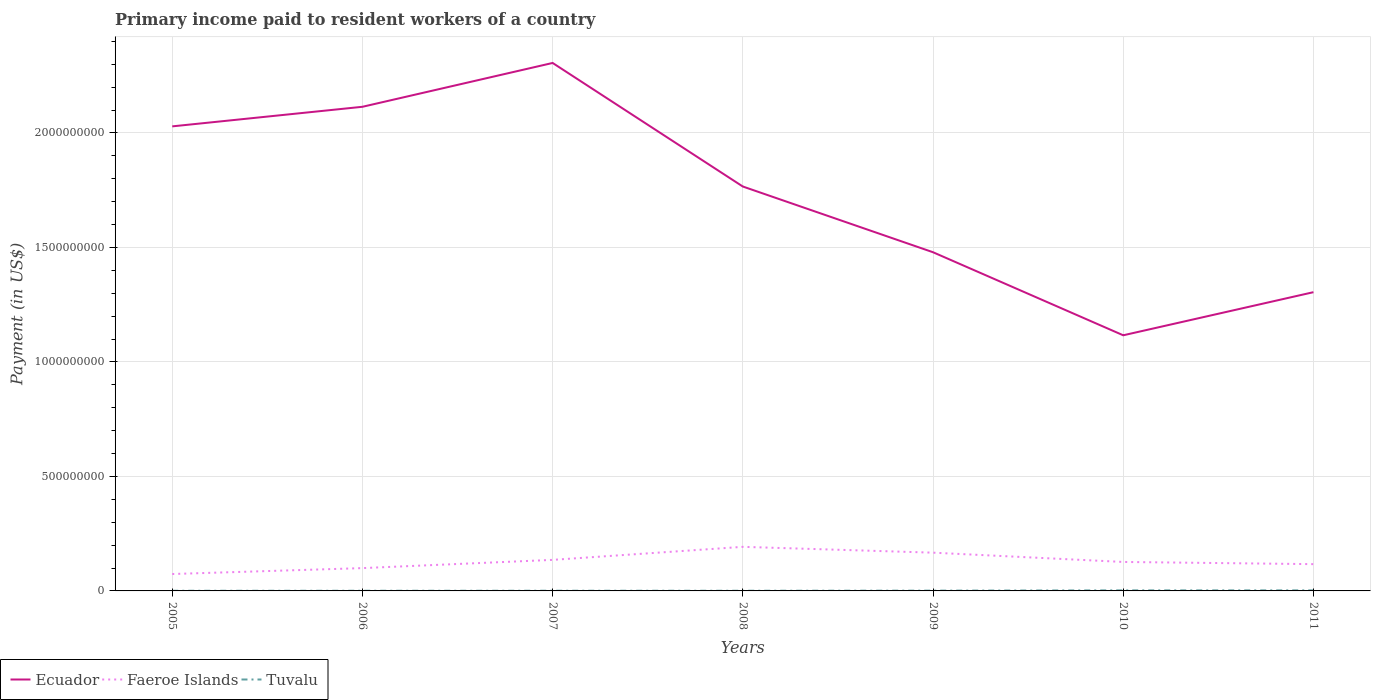Does the line corresponding to Faeroe Islands intersect with the line corresponding to Tuvalu?
Your answer should be compact. No. Across all years, what is the maximum amount paid to workers in Ecuador?
Keep it short and to the point. 1.12e+09. In which year was the amount paid to workers in Faeroe Islands maximum?
Keep it short and to the point. 2005. What is the total amount paid to workers in Tuvalu in the graph?
Your answer should be compact. -1.27e+05. What is the difference between the highest and the second highest amount paid to workers in Ecuador?
Your answer should be compact. 1.19e+09. What is the difference between two consecutive major ticks on the Y-axis?
Give a very brief answer. 5.00e+08. Where does the legend appear in the graph?
Your response must be concise. Bottom left. How are the legend labels stacked?
Offer a terse response. Horizontal. What is the title of the graph?
Give a very brief answer. Primary income paid to resident workers of a country. What is the label or title of the Y-axis?
Offer a very short reply. Payment (in US$). What is the Payment (in US$) of Ecuador in 2005?
Your response must be concise. 2.03e+09. What is the Payment (in US$) of Faeroe Islands in 2005?
Provide a short and direct response. 7.38e+07. What is the Payment (in US$) in Tuvalu in 2005?
Your answer should be very brief. 6.70e+05. What is the Payment (in US$) in Ecuador in 2006?
Provide a short and direct response. 2.11e+09. What is the Payment (in US$) in Faeroe Islands in 2006?
Your answer should be compact. 9.96e+07. What is the Payment (in US$) in Tuvalu in 2006?
Make the answer very short. 7.17e+05. What is the Payment (in US$) in Ecuador in 2007?
Keep it short and to the point. 2.31e+09. What is the Payment (in US$) of Faeroe Islands in 2007?
Keep it short and to the point. 1.36e+08. What is the Payment (in US$) in Tuvalu in 2007?
Your answer should be very brief. 7.97e+05. What is the Payment (in US$) in Ecuador in 2008?
Your response must be concise. 1.77e+09. What is the Payment (in US$) in Faeroe Islands in 2008?
Provide a short and direct response. 1.92e+08. What is the Payment (in US$) in Tuvalu in 2008?
Ensure brevity in your answer.  7.76e+05. What is the Payment (in US$) of Ecuador in 2009?
Provide a short and direct response. 1.48e+09. What is the Payment (in US$) in Faeroe Islands in 2009?
Your answer should be compact. 1.67e+08. What is the Payment (in US$) of Tuvalu in 2009?
Offer a very short reply. 1.23e+06. What is the Payment (in US$) in Ecuador in 2010?
Offer a very short reply. 1.12e+09. What is the Payment (in US$) in Faeroe Islands in 2010?
Ensure brevity in your answer.  1.27e+08. What is the Payment (in US$) in Tuvalu in 2010?
Your response must be concise. 2.42e+06. What is the Payment (in US$) in Ecuador in 2011?
Ensure brevity in your answer.  1.30e+09. What is the Payment (in US$) in Faeroe Islands in 2011?
Make the answer very short. 1.17e+08. What is the Payment (in US$) of Tuvalu in 2011?
Your response must be concise. 2.35e+06. Across all years, what is the maximum Payment (in US$) in Ecuador?
Offer a very short reply. 2.31e+09. Across all years, what is the maximum Payment (in US$) in Faeroe Islands?
Make the answer very short. 1.92e+08. Across all years, what is the maximum Payment (in US$) of Tuvalu?
Offer a very short reply. 2.42e+06. Across all years, what is the minimum Payment (in US$) of Ecuador?
Ensure brevity in your answer.  1.12e+09. Across all years, what is the minimum Payment (in US$) in Faeroe Islands?
Keep it short and to the point. 7.38e+07. Across all years, what is the minimum Payment (in US$) of Tuvalu?
Make the answer very short. 6.70e+05. What is the total Payment (in US$) in Ecuador in the graph?
Provide a short and direct response. 1.21e+1. What is the total Payment (in US$) of Faeroe Islands in the graph?
Keep it short and to the point. 9.12e+08. What is the total Payment (in US$) in Tuvalu in the graph?
Make the answer very short. 8.96e+06. What is the difference between the Payment (in US$) in Ecuador in 2005 and that in 2006?
Your response must be concise. -8.55e+07. What is the difference between the Payment (in US$) of Faeroe Islands in 2005 and that in 2006?
Offer a very short reply. -2.58e+07. What is the difference between the Payment (in US$) of Tuvalu in 2005 and that in 2006?
Give a very brief answer. -4.75e+04. What is the difference between the Payment (in US$) of Ecuador in 2005 and that in 2007?
Make the answer very short. -2.77e+08. What is the difference between the Payment (in US$) in Faeroe Islands in 2005 and that in 2007?
Your answer should be very brief. -6.18e+07. What is the difference between the Payment (in US$) of Tuvalu in 2005 and that in 2007?
Provide a succinct answer. -1.27e+05. What is the difference between the Payment (in US$) of Ecuador in 2005 and that in 2008?
Provide a succinct answer. 2.63e+08. What is the difference between the Payment (in US$) in Faeroe Islands in 2005 and that in 2008?
Provide a short and direct response. -1.19e+08. What is the difference between the Payment (in US$) in Tuvalu in 2005 and that in 2008?
Provide a short and direct response. -1.06e+05. What is the difference between the Payment (in US$) in Ecuador in 2005 and that in 2009?
Keep it short and to the point. 5.50e+08. What is the difference between the Payment (in US$) in Faeroe Islands in 2005 and that in 2009?
Give a very brief answer. -9.32e+07. What is the difference between the Payment (in US$) of Tuvalu in 2005 and that in 2009?
Your response must be concise. -5.58e+05. What is the difference between the Payment (in US$) of Ecuador in 2005 and that in 2010?
Offer a very short reply. 9.12e+08. What is the difference between the Payment (in US$) of Faeroe Islands in 2005 and that in 2010?
Give a very brief answer. -5.27e+07. What is the difference between the Payment (in US$) of Tuvalu in 2005 and that in 2010?
Offer a very short reply. -1.75e+06. What is the difference between the Payment (in US$) of Ecuador in 2005 and that in 2011?
Make the answer very short. 7.24e+08. What is the difference between the Payment (in US$) in Faeroe Islands in 2005 and that in 2011?
Provide a succinct answer. -4.31e+07. What is the difference between the Payment (in US$) in Tuvalu in 2005 and that in 2011?
Provide a succinct answer. -1.68e+06. What is the difference between the Payment (in US$) of Ecuador in 2006 and that in 2007?
Your response must be concise. -1.91e+08. What is the difference between the Payment (in US$) in Faeroe Islands in 2006 and that in 2007?
Provide a succinct answer. -3.60e+07. What is the difference between the Payment (in US$) in Tuvalu in 2006 and that in 2007?
Give a very brief answer. -7.97e+04. What is the difference between the Payment (in US$) in Ecuador in 2006 and that in 2008?
Offer a very short reply. 3.48e+08. What is the difference between the Payment (in US$) of Faeroe Islands in 2006 and that in 2008?
Offer a terse response. -9.29e+07. What is the difference between the Payment (in US$) of Tuvalu in 2006 and that in 2008?
Make the answer very short. -5.88e+04. What is the difference between the Payment (in US$) of Ecuador in 2006 and that in 2009?
Your answer should be compact. 6.35e+08. What is the difference between the Payment (in US$) of Faeroe Islands in 2006 and that in 2009?
Ensure brevity in your answer.  -6.74e+07. What is the difference between the Payment (in US$) in Tuvalu in 2006 and that in 2009?
Provide a short and direct response. -5.10e+05. What is the difference between the Payment (in US$) in Ecuador in 2006 and that in 2010?
Offer a very short reply. 9.98e+08. What is the difference between the Payment (in US$) of Faeroe Islands in 2006 and that in 2010?
Provide a succinct answer. -2.69e+07. What is the difference between the Payment (in US$) in Tuvalu in 2006 and that in 2010?
Make the answer very short. -1.70e+06. What is the difference between the Payment (in US$) in Ecuador in 2006 and that in 2011?
Provide a short and direct response. 8.10e+08. What is the difference between the Payment (in US$) of Faeroe Islands in 2006 and that in 2011?
Your response must be concise. -1.73e+07. What is the difference between the Payment (in US$) in Tuvalu in 2006 and that in 2011?
Your response must be concise. -1.63e+06. What is the difference between the Payment (in US$) of Ecuador in 2007 and that in 2008?
Your answer should be compact. 5.40e+08. What is the difference between the Payment (in US$) in Faeroe Islands in 2007 and that in 2008?
Offer a terse response. -5.69e+07. What is the difference between the Payment (in US$) of Tuvalu in 2007 and that in 2008?
Offer a terse response. 2.09e+04. What is the difference between the Payment (in US$) in Ecuador in 2007 and that in 2009?
Provide a short and direct response. 8.27e+08. What is the difference between the Payment (in US$) of Faeroe Islands in 2007 and that in 2009?
Ensure brevity in your answer.  -3.14e+07. What is the difference between the Payment (in US$) of Tuvalu in 2007 and that in 2009?
Your response must be concise. -4.31e+05. What is the difference between the Payment (in US$) in Ecuador in 2007 and that in 2010?
Provide a short and direct response. 1.19e+09. What is the difference between the Payment (in US$) of Faeroe Islands in 2007 and that in 2010?
Offer a very short reply. 9.08e+06. What is the difference between the Payment (in US$) of Tuvalu in 2007 and that in 2010?
Make the answer very short. -1.62e+06. What is the difference between the Payment (in US$) in Ecuador in 2007 and that in 2011?
Offer a very short reply. 1.00e+09. What is the difference between the Payment (in US$) of Faeroe Islands in 2007 and that in 2011?
Keep it short and to the point. 1.87e+07. What is the difference between the Payment (in US$) in Tuvalu in 2007 and that in 2011?
Give a very brief answer. -1.55e+06. What is the difference between the Payment (in US$) of Ecuador in 2008 and that in 2009?
Your answer should be compact. 2.87e+08. What is the difference between the Payment (in US$) in Faeroe Islands in 2008 and that in 2009?
Offer a very short reply. 2.55e+07. What is the difference between the Payment (in US$) of Tuvalu in 2008 and that in 2009?
Provide a succinct answer. -4.52e+05. What is the difference between the Payment (in US$) in Ecuador in 2008 and that in 2010?
Give a very brief answer. 6.50e+08. What is the difference between the Payment (in US$) of Faeroe Islands in 2008 and that in 2010?
Provide a short and direct response. 6.60e+07. What is the difference between the Payment (in US$) of Tuvalu in 2008 and that in 2010?
Make the answer very short. -1.64e+06. What is the difference between the Payment (in US$) in Ecuador in 2008 and that in 2011?
Make the answer very short. 4.61e+08. What is the difference between the Payment (in US$) of Faeroe Islands in 2008 and that in 2011?
Make the answer very short. 7.56e+07. What is the difference between the Payment (in US$) of Tuvalu in 2008 and that in 2011?
Ensure brevity in your answer.  -1.57e+06. What is the difference between the Payment (in US$) of Ecuador in 2009 and that in 2010?
Give a very brief answer. 3.63e+08. What is the difference between the Payment (in US$) of Faeroe Islands in 2009 and that in 2010?
Provide a short and direct response. 4.05e+07. What is the difference between the Payment (in US$) in Tuvalu in 2009 and that in 2010?
Provide a succinct answer. -1.19e+06. What is the difference between the Payment (in US$) in Ecuador in 2009 and that in 2011?
Give a very brief answer. 1.74e+08. What is the difference between the Payment (in US$) in Faeroe Islands in 2009 and that in 2011?
Ensure brevity in your answer.  5.01e+07. What is the difference between the Payment (in US$) of Tuvalu in 2009 and that in 2011?
Keep it short and to the point. -1.12e+06. What is the difference between the Payment (in US$) in Ecuador in 2010 and that in 2011?
Give a very brief answer. -1.88e+08. What is the difference between the Payment (in US$) in Faeroe Islands in 2010 and that in 2011?
Your answer should be very brief. 9.58e+06. What is the difference between the Payment (in US$) of Tuvalu in 2010 and that in 2011?
Make the answer very short. 7.36e+04. What is the difference between the Payment (in US$) of Ecuador in 2005 and the Payment (in US$) of Faeroe Islands in 2006?
Make the answer very short. 1.93e+09. What is the difference between the Payment (in US$) in Ecuador in 2005 and the Payment (in US$) in Tuvalu in 2006?
Your answer should be very brief. 2.03e+09. What is the difference between the Payment (in US$) of Faeroe Islands in 2005 and the Payment (in US$) of Tuvalu in 2006?
Provide a short and direct response. 7.31e+07. What is the difference between the Payment (in US$) of Ecuador in 2005 and the Payment (in US$) of Faeroe Islands in 2007?
Provide a succinct answer. 1.89e+09. What is the difference between the Payment (in US$) in Ecuador in 2005 and the Payment (in US$) in Tuvalu in 2007?
Offer a very short reply. 2.03e+09. What is the difference between the Payment (in US$) in Faeroe Islands in 2005 and the Payment (in US$) in Tuvalu in 2007?
Your response must be concise. 7.30e+07. What is the difference between the Payment (in US$) of Ecuador in 2005 and the Payment (in US$) of Faeroe Islands in 2008?
Your response must be concise. 1.84e+09. What is the difference between the Payment (in US$) in Ecuador in 2005 and the Payment (in US$) in Tuvalu in 2008?
Provide a short and direct response. 2.03e+09. What is the difference between the Payment (in US$) of Faeroe Islands in 2005 and the Payment (in US$) of Tuvalu in 2008?
Your answer should be compact. 7.31e+07. What is the difference between the Payment (in US$) of Ecuador in 2005 and the Payment (in US$) of Faeroe Islands in 2009?
Ensure brevity in your answer.  1.86e+09. What is the difference between the Payment (in US$) of Ecuador in 2005 and the Payment (in US$) of Tuvalu in 2009?
Keep it short and to the point. 2.03e+09. What is the difference between the Payment (in US$) in Faeroe Islands in 2005 and the Payment (in US$) in Tuvalu in 2009?
Your response must be concise. 7.26e+07. What is the difference between the Payment (in US$) in Ecuador in 2005 and the Payment (in US$) in Faeroe Islands in 2010?
Make the answer very short. 1.90e+09. What is the difference between the Payment (in US$) in Ecuador in 2005 and the Payment (in US$) in Tuvalu in 2010?
Your answer should be compact. 2.03e+09. What is the difference between the Payment (in US$) of Faeroe Islands in 2005 and the Payment (in US$) of Tuvalu in 2010?
Your response must be concise. 7.14e+07. What is the difference between the Payment (in US$) in Ecuador in 2005 and the Payment (in US$) in Faeroe Islands in 2011?
Provide a short and direct response. 1.91e+09. What is the difference between the Payment (in US$) of Ecuador in 2005 and the Payment (in US$) of Tuvalu in 2011?
Provide a succinct answer. 2.03e+09. What is the difference between the Payment (in US$) in Faeroe Islands in 2005 and the Payment (in US$) in Tuvalu in 2011?
Offer a very short reply. 7.15e+07. What is the difference between the Payment (in US$) in Ecuador in 2006 and the Payment (in US$) in Faeroe Islands in 2007?
Offer a very short reply. 1.98e+09. What is the difference between the Payment (in US$) in Ecuador in 2006 and the Payment (in US$) in Tuvalu in 2007?
Ensure brevity in your answer.  2.11e+09. What is the difference between the Payment (in US$) in Faeroe Islands in 2006 and the Payment (in US$) in Tuvalu in 2007?
Offer a terse response. 9.88e+07. What is the difference between the Payment (in US$) in Ecuador in 2006 and the Payment (in US$) in Faeroe Islands in 2008?
Offer a terse response. 1.92e+09. What is the difference between the Payment (in US$) of Ecuador in 2006 and the Payment (in US$) of Tuvalu in 2008?
Give a very brief answer. 2.11e+09. What is the difference between the Payment (in US$) of Faeroe Islands in 2006 and the Payment (in US$) of Tuvalu in 2008?
Your response must be concise. 9.88e+07. What is the difference between the Payment (in US$) in Ecuador in 2006 and the Payment (in US$) in Faeroe Islands in 2009?
Give a very brief answer. 1.95e+09. What is the difference between the Payment (in US$) of Ecuador in 2006 and the Payment (in US$) of Tuvalu in 2009?
Provide a short and direct response. 2.11e+09. What is the difference between the Payment (in US$) of Faeroe Islands in 2006 and the Payment (in US$) of Tuvalu in 2009?
Give a very brief answer. 9.84e+07. What is the difference between the Payment (in US$) of Ecuador in 2006 and the Payment (in US$) of Faeroe Islands in 2010?
Ensure brevity in your answer.  1.99e+09. What is the difference between the Payment (in US$) of Ecuador in 2006 and the Payment (in US$) of Tuvalu in 2010?
Ensure brevity in your answer.  2.11e+09. What is the difference between the Payment (in US$) in Faeroe Islands in 2006 and the Payment (in US$) in Tuvalu in 2010?
Offer a very short reply. 9.72e+07. What is the difference between the Payment (in US$) in Ecuador in 2006 and the Payment (in US$) in Faeroe Islands in 2011?
Give a very brief answer. 2.00e+09. What is the difference between the Payment (in US$) in Ecuador in 2006 and the Payment (in US$) in Tuvalu in 2011?
Give a very brief answer. 2.11e+09. What is the difference between the Payment (in US$) in Faeroe Islands in 2006 and the Payment (in US$) in Tuvalu in 2011?
Your answer should be very brief. 9.73e+07. What is the difference between the Payment (in US$) of Ecuador in 2007 and the Payment (in US$) of Faeroe Islands in 2008?
Provide a short and direct response. 2.11e+09. What is the difference between the Payment (in US$) in Ecuador in 2007 and the Payment (in US$) in Tuvalu in 2008?
Provide a short and direct response. 2.30e+09. What is the difference between the Payment (in US$) in Faeroe Islands in 2007 and the Payment (in US$) in Tuvalu in 2008?
Your answer should be very brief. 1.35e+08. What is the difference between the Payment (in US$) in Ecuador in 2007 and the Payment (in US$) in Faeroe Islands in 2009?
Offer a terse response. 2.14e+09. What is the difference between the Payment (in US$) of Ecuador in 2007 and the Payment (in US$) of Tuvalu in 2009?
Offer a terse response. 2.30e+09. What is the difference between the Payment (in US$) of Faeroe Islands in 2007 and the Payment (in US$) of Tuvalu in 2009?
Your response must be concise. 1.34e+08. What is the difference between the Payment (in US$) of Ecuador in 2007 and the Payment (in US$) of Faeroe Islands in 2010?
Make the answer very short. 2.18e+09. What is the difference between the Payment (in US$) in Ecuador in 2007 and the Payment (in US$) in Tuvalu in 2010?
Ensure brevity in your answer.  2.30e+09. What is the difference between the Payment (in US$) of Faeroe Islands in 2007 and the Payment (in US$) of Tuvalu in 2010?
Your response must be concise. 1.33e+08. What is the difference between the Payment (in US$) in Ecuador in 2007 and the Payment (in US$) in Faeroe Islands in 2011?
Give a very brief answer. 2.19e+09. What is the difference between the Payment (in US$) in Ecuador in 2007 and the Payment (in US$) in Tuvalu in 2011?
Your response must be concise. 2.30e+09. What is the difference between the Payment (in US$) of Faeroe Islands in 2007 and the Payment (in US$) of Tuvalu in 2011?
Keep it short and to the point. 1.33e+08. What is the difference between the Payment (in US$) in Ecuador in 2008 and the Payment (in US$) in Faeroe Islands in 2009?
Provide a succinct answer. 1.60e+09. What is the difference between the Payment (in US$) in Ecuador in 2008 and the Payment (in US$) in Tuvalu in 2009?
Give a very brief answer. 1.76e+09. What is the difference between the Payment (in US$) in Faeroe Islands in 2008 and the Payment (in US$) in Tuvalu in 2009?
Give a very brief answer. 1.91e+08. What is the difference between the Payment (in US$) of Ecuador in 2008 and the Payment (in US$) of Faeroe Islands in 2010?
Keep it short and to the point. 1.64e+09. What is the difference between the Payment (in US$) of Ecuador in 2008 and the Payment (in US$) of Tuvalu in 2010?
Offer a terse response. 1.76e+09. What is the difference between the Payment (in US$) of Faeroe Islands in 2008 and the Payment (in US$) of Tuvalu in 2010?
Your answer should be very brief. 1.90e+08. What is the difference between the Payment (in US$) in Ecuador in 2008 and the Payment (in US$) in Faeroe Islands in 2011?
Give a very brief answer. 1.65e+09. What is the difference between the Payment (in US$) in Ecuador in 2008 and the Payment (in US$) in Tuvalu in 2011?
Offer a very short reply. 1.76e+09. What is the difference between the Payment (in US$) in Faeroe Islands in 2008 and the Payment (in US$) in Tuvalu in 2011?
Make the answer very short. 1.90e+08. What is the difference between the Payment (in US$) of Ecuador in 2009 and the Payment (in US$) of Faeroe Islands in 2010?
Give a very brief answer. 1.35e+09. What is the difference between the Payment (in US$) of Ecuador in 2009 and the Payment (in US$) of Tuvalu in 2010?
Ensure brevity in your answer.  1.48e+09. What is the difference between the Payment (in US$) in Faeroe Islands in 2009 and the Payment (in US$) in Tuvalu in 2010?
Provide a short and direct response. 1.65e+08. What is the difference between the Payment (in US$) of Ecuador in 2009 and the Payment (in US$) of Faeroe Islands in 2011?
Offer a very short reply. 1.36e+09. What is the difference between the Payment (in US$) in Ecuador in 2009 and the Payment (in US$) in Tuvalu in 2011?
Offer a terse response. 1.48e+09. What is the difference between the Payment (in US$) of Faeroe Islands in 2009 and the Payment (in US$) of Tuvalu in 2011?
Your answer should be very brief. 1.65e+08. What is the difference between the Payment (in US$) in Ecuador in 2010 and the Payment (in US$) in Faeroe Islands in 2011?
Your response must be concise. 9.99e+08. What is the difference between the Payment (in US$) of Ecuador in 2010 and the Payment (in US$) of Tuvalu in 2011?
Provide a succinct answer. 1.11e+09. What is the difference between the Payment (in US$) of Faeroe Islands in 2010 and the Payment (in US$) of Tuvalu in 2011?
Your answer should be very brief. 1.24e+08. What is the average Payment (in US$) in Ecuador per year?
Your response must be concise. 1.73e+09. What is the average Payment (in US$) of Faeroe Islands per year?
Keep it short and to the point. 1.30e+08. What is the average Payment (in US$) of Tuvalu per year?
Give a very brief answer. 1.28e+06. In the year 2005, what is the difference between the Payment (in US$) of Ecuador and Payment (in US$) of Faeroe Islands?
Keep it short and to the point. 1.95e+09. In the year 2005, what is the difference between the Payment (in US$) in Ecuador and Payment (in US$) in Tuvalu?
Your answer should be very brief. 2.03e+09. In the year 2005, what is the difference between the Payment (in US$) in Faeroe Islands and Payment (in US$) in Tuvalu?
Give a very brief answer. 7.32e+07. In the year 2006, what is the difference between the Payment (in US$) in Ecuador and Payment (in US$) in Faeroe Islands?
Provide a succinct answer. 2.01e+09. In the year 2006, what is the difference between the Payment (in US$) of Ecuador and Payment (in US$) of Tuvalu?
Keep it short and to the point. 2.11e+09. In the year 2006, what is the difference between the Payment (in US$) in Faeroe Islands and Payment (in US$) in Tuvalu?
Your answer should be compact. 9.89e+07. In the year 2007, what is the difference between the Payment (in US$) of Ecuador and Payment (in US$) of Faeroe Islands?
Offer a terse response. 2.17e+09. In the year 2007, what is the difference between the Payment (in US$) of Ecuador and Payment (in US$) of Tuvalu?
Offer a very short reply. 2.30e+09. In the year 2007, what is the difference between the Payment (in US$) of Faeroe Islands and Payment (in US$) of Tuvalu?
Your response must be concise. 1.35e+08. In the year 2008, what is the difference between the Payment (in US$) of Ecuador and Payment (in US$) of Faeroe Islands?
Your response must be concise. 1.57e+09. In the year 2008, what is the difference between the Payment (in US$) in Ecuador and Payment (in US$) in Tuvalu?
Keep it short and to the point. 1.77e+09. In the year 2008, what is the difference between the Payment (in US$) of Faeroe Islands and Payment (in US$) of Tuvalu?
Your answer should be compact. 1.92e+08. In the year 2009, what is the difference between the Payment (in US$) of Ecuador and Payment (in US$) of Faeroe Islands?
Give a very brief answer. 1.31e+09. In the year 2009, what is the difference between the Payment (in US$) of Ecuador and Payment (in US$) of Tuvalu?
Your answer should be very brief. 1.48e+09. In the year 2009, what is the difference between the Payment (in US$) of Faeroe Islands and Payment (in US$) of Tuvalu?
Offer a very short reply. 1.66e+08. In the year 2010, what is the difference between the Payment (in US$) in Ecuador and Payment (in US$) in Faeroe Islands?
Give a very brief answer. 9.90e+08. In the year 2010, what is the difference between the Payment (in US$) in Ecuador and Payment (in US$) in Tuvalu?
Ensure brevity in your answer.  1.11e+09. In the year 2010, what is the difference between the Payment (in US$) in Faeroe Islands and Payment (in US$) in Tuvalu?
Your answer should be compact. 1.24e+08. In the year 2011, what is the difference between the Payment (in US$) of Ecuador and Payment (in US$) of Faeroe Islands?
Offer a terse response. 1.19e+09. In the year 2011, what is the difference between the Payment (in US$) in Ecuador and Payment (in US$) in Tuvalu?
Keep it short and to the point. 1.30e+09. In the year 2011, what is the difference between the Payment (in US$) of Faeroe Islands and Payment (in US$) of Tuvalu?
Offer a very short reply. 1.15e+08. What is the ratio of the Payment (in US$) in Ecuador in 2005 to that in 2006?
Your response must be concise. 0.96. What is the ratio of the Payment (in US$) in Faeroe Islands in 2005 to that in 2006?
Your response must be concise. 0.74. What is the ratio of the Payment (in US$) of Tuvalu in 2005 to that in 2006?
Provide a short and direct response. 0.93. What is the ratio of the Payment (in US$) in Ecuador in 2005 to that in 2007?
Provide a short and direct response. 0.88. What is the ratio of the Payment (in US$) in Faeroe Islands in 2005 to that in 2007?
Provide a succinct answer. 0.54. What is the ratio of the Payment (in US$) in Tuvalu in 2005 to that in 2007?
Ensure brevity in your answer.  0.84. What is the ratio of the Payment (in US$) of Ecuador in 2005 to that in 2008?
Offer a very short reply. 1.15. What is the ratio of the Payment (in US$) in Faeroe Islands in 2005 to that in 2008?
Provide a short and direct response. 0.38. What is the ratio of the Payment (in US$) of Tuvalu in 2005 to that in 2008?
Give a very brief answer. 0.86. What is the ratio of the Payment (in US$) of Ecuador in 2005 to that in 2009?
Ensure brevity in your answer.  1.37. What is the ratio of the Payment (in US$) of Faeroe Islands in 2005 to that in 2009?
Provide a short and direct response. 0.44. What is the ratio of the Payment (in US$) of Tuvalu in 2005 to that in 2009?
Provide a succinct answer. 0.55. What is the ratio of the Payment (in US$) in Ecuador in 2005 to that in 2010?
Provide a short and direct response. 1.82. What is the ratio of the Payment (in US$) in Faeroe Islands in 2005 to that in 2010?
Give a very brief answer. 0.58. What is the ratio of the Payment (in US$) in Tuvalu in 2005 to that in 2010?
Offer a terse response. 0.28. What is the ratio of the Payment (in US$) of Ecuador in 2005 to that in 2011?
Provide a succinct answer. 1.55. What is the ratio of the Payment (in US$) in Faeroe Islands in 2005 to that in 2011?
Provide a short and direct response. 0.63. What is the ratio of the Payment (in US$) of Tuvalu in 2005 to that in 2011?
Keep it short and to the point. 0.29. What is the ratio of the Payment (in US$) in Ecuador in 2006 to that in 2007?
Your answer should be compact. 0.92. What is the ratio of the Payment (in US$) of Faeroe Islands in 2006 to that in 2007?
Your answer should be compact. 0.73. What is the ratio of the Payment (in US$) in Ecuador in 2006 to that in 2008?
Your answer should be compact. 1.2. What is the ratio of the Payment (in US$) in Faeroe Islands in 2006 to that in 2008?
Ensure brevity in your answer.  0.52. What is the ratio of the Payment (in US$) in Tuvalu in 2006 to that in 2008?
Ensure brevity in your answer.  0.92. What is the ratio of the Payment (in US$) in Ecuador in 2006 to that in 2009?
Offer a terse response. 1.43. What is the ratio of the Payment (in US$) in Faeroe Islands in 2006 to that in 2009?
Ensure brevity in your answer.  0.6. What is the ratio of the Payment (in US$) of Tuvalu in 2006 to that in 2009?
Ensure brevity in your answer.  0.58. What is the ratio of the Payment (in US$) in Ecuador in 2006 to that in 2010?
Your answer should be compact. 1.89. What is the ratio of the Payment (in US$) in Faeroe Islands in 2006 to that in 2010?
Give a very brief answer. 0.79. What is the ratio of the Payment (in US$) of Tuvalu in 2006 to that in 2010?
Make the answer very short. 0.3. What is the ratio of the Payment (in US$) in Ecuador in 2006 to that in 2011?
Offer a very short reply. 1.62. What is the ratio of the Payment (in US$) in Faeroe Islands in 2006 to that in 2011?
Your response must be concise. 0.85. What is the ratio of the Payment (in US$) in Tuvalu in 2006 to that in 2011?
Your answer should be compact. 0.31. What is the ratio of the Payment (in US$) of Ecuador in 2007 to that in 2008?
Make the answer very short. 1.31. What is the ratio of the Payment (in US$) of Faeroe Islands in 2007 to that in 2008?
Provide a succinct answer. 0.7. What is the ratio of the Payment (in US$) of Tuvalu in 2007 to that in 2008?
Make the answer very short. 1.03. What is the ratio of the Payment (in US$) in Ecuador in 2007 to that in 2009?
Offer a very short reply. 1.56. What is the ratio of the Payment (in US$) in Faeroe Islands in 2007 to that in 2009?
Ensure brevity in your answer.  0.81. What is the ratio of the Payment (in US$) in Tuvalu in 2007 to that in 2009?
Offer a very short reply. 0.65. What is the ratio of the Payment (in US$) of Ecuador in 2007 to that in 2010?
Your answer should be compact. 2.07. What is the ratio of the Payment (in US$) in Faeroe Islands in 2007 to that in 2010?
Offer a very short reply. 1.07. What is the ratio of the Payment (in US$) of Tuvalu in 2007 to that in 2010?
Provide a succinct answer. 0.33. What is the ratio of the Payment (in US$) in Ecuador in 2007 to that in 2011?
Provide a succinct answer. 1.77. What is the ratio of the Payment (in US$) of Faeroe Islands in 2007 to that in 2011?
Your answer should be compact. 1.16. What is the ratio of the Payment (in US$) of Tuvalu in 2007 to that in 2011?
Offer a terse response. 0.34. What is the ratio of the Payment (in US$) in Ecuador in 2008 to that in 2009?
Your answer should be compact. 1.19. What is the ratio of the Payment (in US$) of Faeroe Islands in 2008 to that in 2009?
Offer a very short reply. 1.15. What is the ratio of the Payment (in US$) in Tuvalu in 2008 to that in 2009?
Make the answer very short. 0.63. What is the ratio of the Payment (in US$) in Ecuador in 2008 to that in 2010?
Provide a succinct answer. 1.58. What is the ratio of the Payment (in US$) in Faeroe Islands in 2008 to that in 2010?
Your response must be concise. 1.52. What is the ratio of the Payment (in US$) of Tuvalu in 2008 to that in 2010?
Make the answer very short. 0.32. What is the ratio of the Payment (in US$) of Ecuador in 2008 to that in 2011?
Keep it short and to the point. 1.35. What is the ratio of the Payment (in US$) in Faeroe Islands in 2008 to that in 2011?
Offer a very short reply. 1.65. What is the ratio of the Payment (in US$) of Tuvalu in 2008 to that in 2011?
Your answer should be very brief. 0.33. What is the ratio of the Payment (in US$) in Ecuador in 2009 to that in 2010?
Your answer should be compact. 1.32. What is the ratio of the Payment (in US$) in Faeroe Islands in 2009 to that in 2010?
Your answer should be very brief. 1.32. What is the ratio of the Payment (in US$) in Tuvalu in 2009 to that in 2010?
Keep it short and to the point. 0.51. What is the ratio of the Payment (in US$) of Ecuador in 2009 to that in 2011?
Make the answer very short. 1.13. What is the ratio of the Payment (in US$) in Faeroe Islands in 2009 to that in 2011?
Your response must be concise. 1.43. What is the ratio of the Payment (in US$) of Tuvalu in 2009 to that in 2011?
Ensure brevity in your answer.  0.52. What is the ratio of the Payment (in US$) of Ecuador in 2010 to that in 2011?
Your answer should be very brief. 0.86. What is the ratio of the Payment (in US$) in Faeroe Islands in 2010 to that in 2011?
Your response must be concise. 1.08. What is the ratio of the Payment (in US$) in Tuvalu in 2010 to that in 2011?
Provide a succinct answer. 1.03. What is the difference between the highest and the second highest Payment (in US$) of Ecuador?
Your answer should be compact. 1.91e+08. What is the difference between the highest and the second highest Payment (in US$) in Faeroe Islands?
Keep it short and to the point. 2.55e+07. What is the difference between the highest and the second highest Payment (in US$) of Tuvalu?
Make the answer very short. 7.36e+04. What is the difference between the highest and the lowest Payment (in US$) of Ecuador?
Offer a terse response. 1.19e+09. What is the difference between the highest and the lowest Payment (in US$) in Faeroe Islands?
Your answer should be very brief. 1.19e+08. What is the difference between the highest and the lowest Payment (in US$) in Tuvalu?
Offer a very short reply. 1.75e+06. 